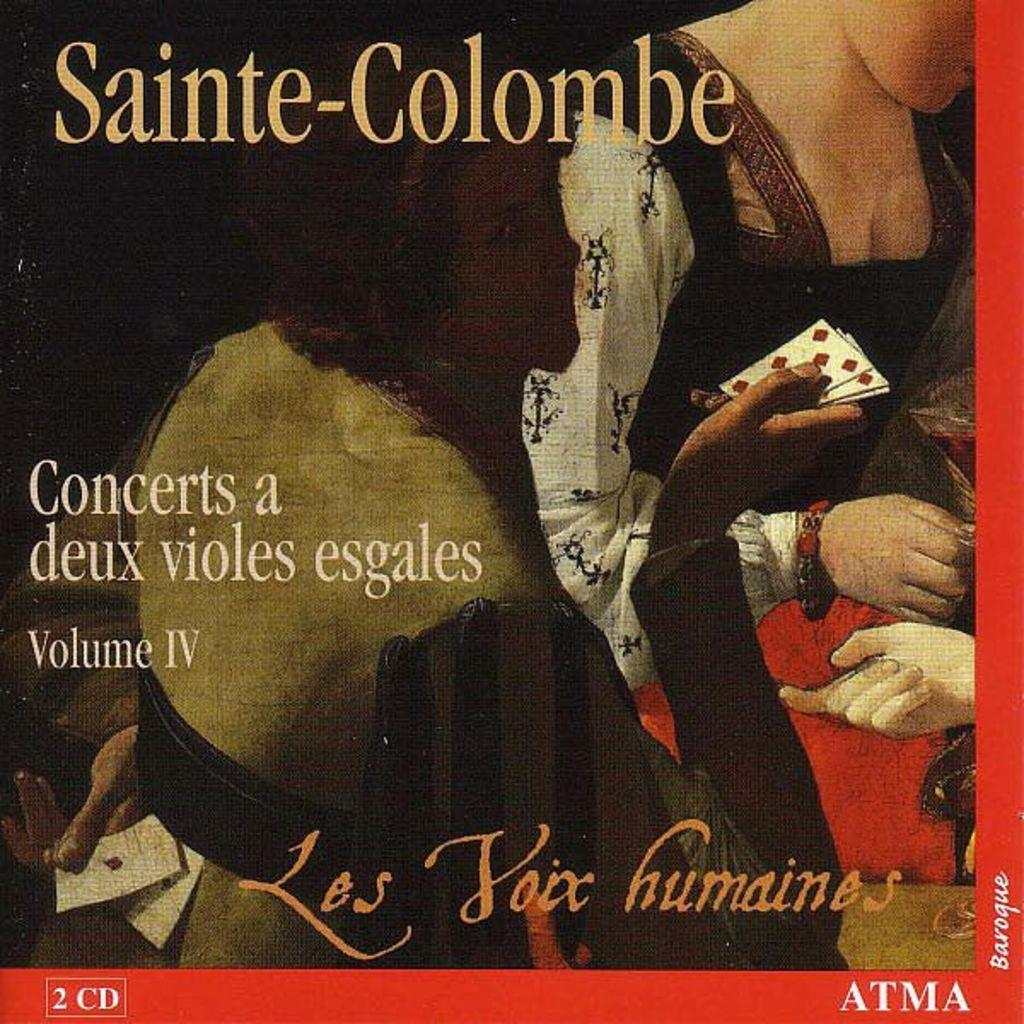What can be seen hanging on the wall in the image? There is a poster in the image. What type of garden can be seen in the image? There is no garden present in the image; it only features a poster on the wall. Who is the representative in the image? There is no representative present in the image; it only features a poster on the wall. 